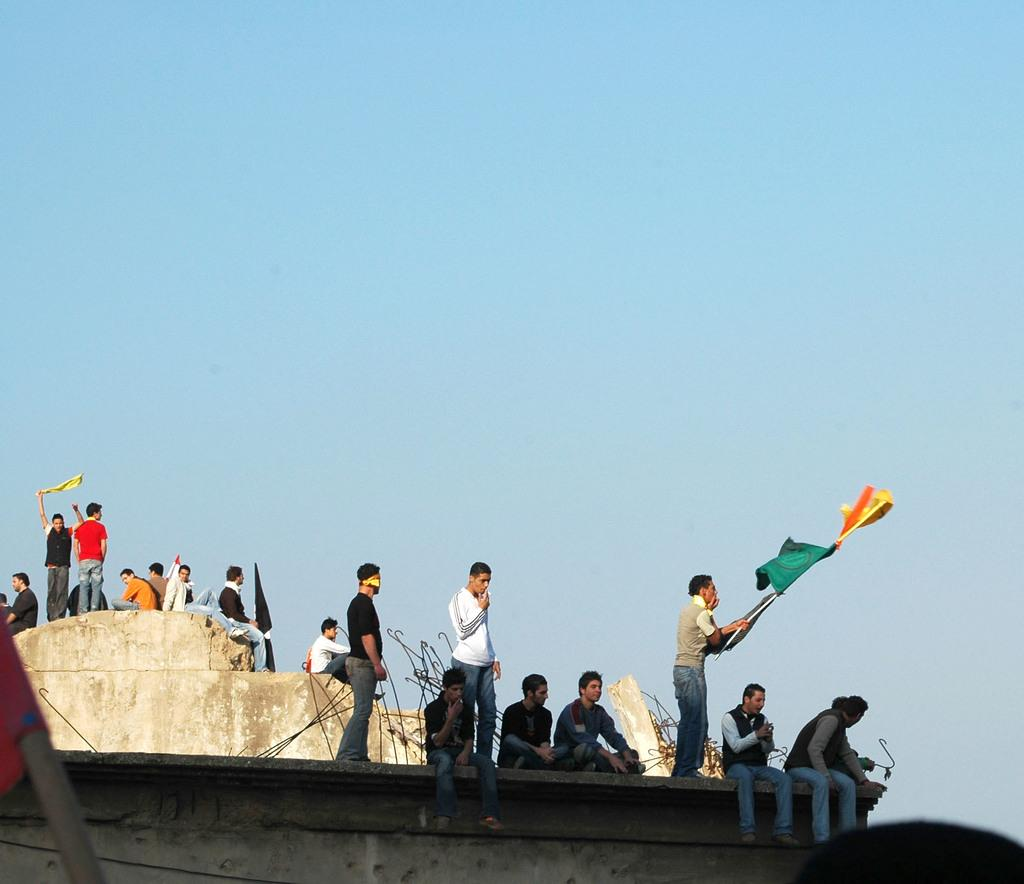What are the people in the image doing? There are people sitting on a wall in the image. What is the wall covered with? The wall is covered with rods. Where are the people holding flags located in the image? The people holding flags are on the left side of the image. What position are these people holding flags in? These people are standing. What type of donkey can be seen shaking the wall in the image? There is no donkey present in the image, and the wall is not being shaken. What material is the stone used to build the wall in the image? The provided facts do not mention the material used to build the wall, so we cannot determine the type of stone used. 